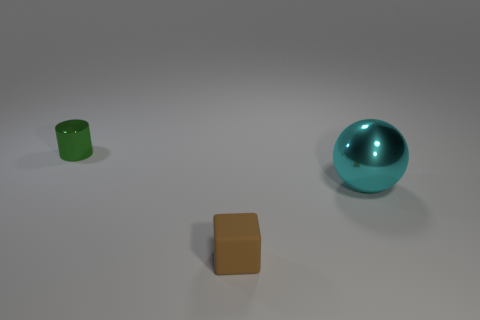What materials are the objects in the image made of? The sphere appears to be made of a reflective material, possibly metal, and the cube looks like it has a matte finish, perhaps made of plastic or painted wood. The cylindrical object also seems to have a matte texture. 